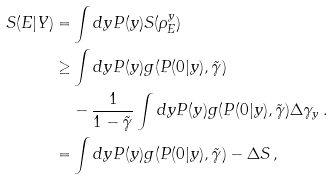Convert formula to latex. <formula><loc_0><loc_0><loc_500><loc_500>S ( E | Y ) = & \int d y P ( y ) S ( \rho _ { E } ^ { y } ) \\ \geq & \int d y P ( y ) g ( P ( 0 | y ) , \tilde { \gamma } ) \\ & - \frac { 1 } { 1 - \tilde { \gamma } } \int d y P ( y ) g ( P ( 0 | y ) , \tilde { \gamma } ) \Delta \gamma _ { y } \, . \\ = & \int d y P ( y ) g ( P ( 0 | y ) , \tilde { \gamma } ) - \Delta S \, ,</formula> 